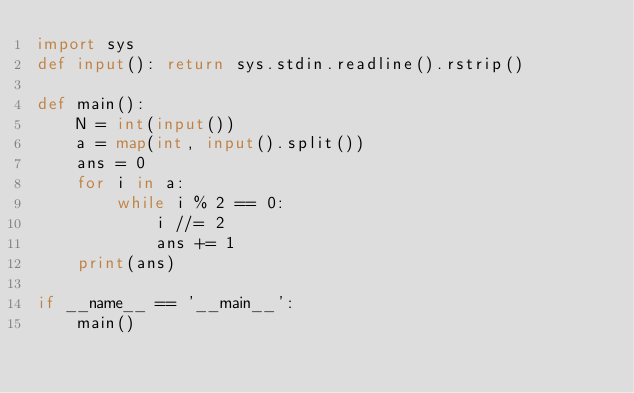Convert code to text. <code><loc_0><loc_0><loc_500><loc_500><_Python_>import sys
def input(): return sys.stdin.readline().rstrip()

def main():
    N = int(input())
    a = map(int, input().split())
    ans = 0
    for i in a:
        while i % 2 == 0:
            i //= 2
            ans += 1
    print(ans)

if __name__ == '__main__':
    main()
</code> 